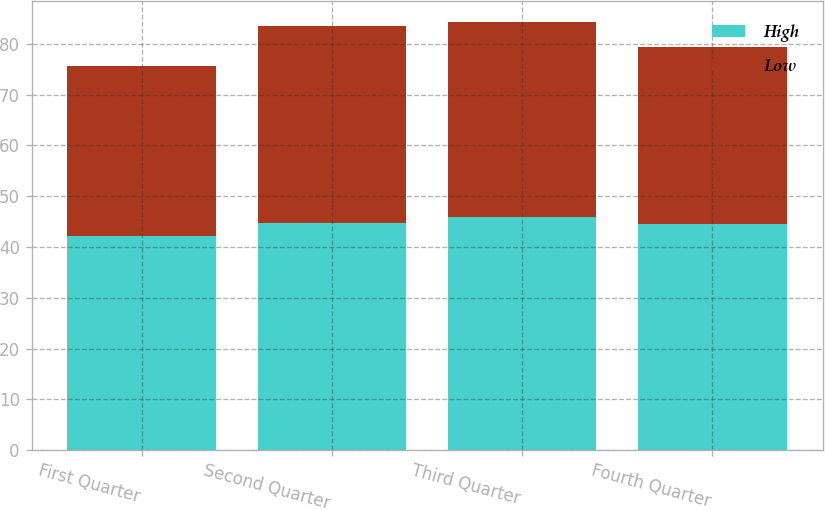<chart> <loc_0><loc_0><loc_500><loc_500><stacked_bar_chart><ecel><fcel>First Quarter<fcel>Second Quarter<fcel>Third Quarter<fcel>Fourth Quarter<nl><fcel>High<fcel>42.11<fcel>44.65<fcel>45.96<fcel>44.44<nl><fcel>Low<fcel>33.61<fcel>38.93<fcel>38.34<fcel>34.95<nl></chart> 